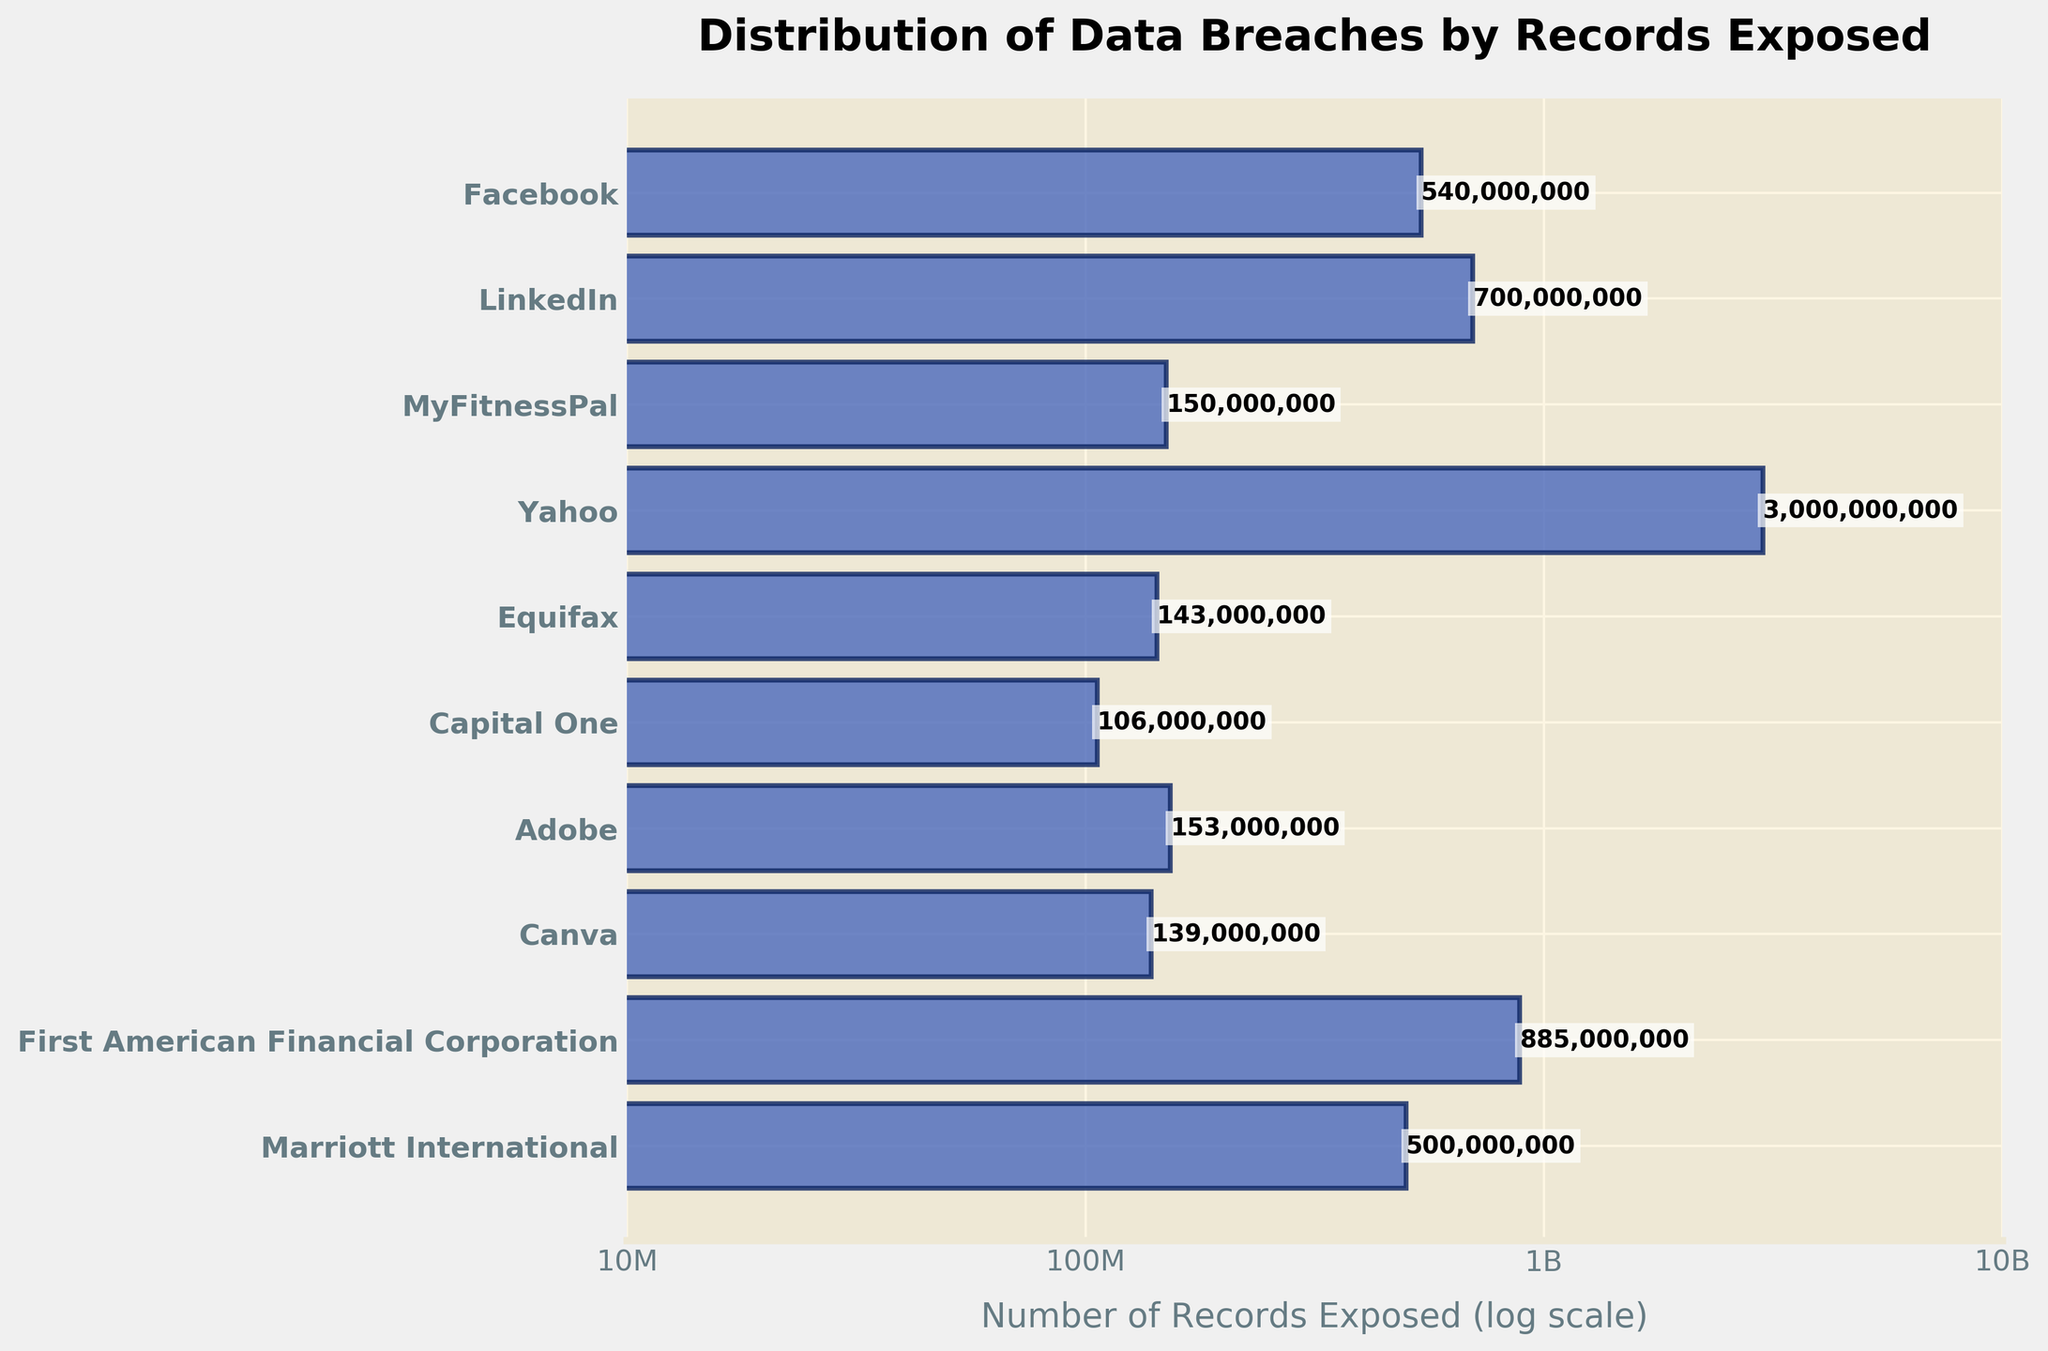what is the title of the plot? The title of the plot is located at the top of the figure. It should be read directly from there. The title provides context about what the figure represents.
Answer: Distribution of Data Breaches by Records Exposed which entity has the largest number of records exposed? Look for the bar that extends the farthest to the right on the horizontal axis. The label next to this bar represents the entity with the largest number of records exposed.
Answer: Yahoo how many records were exposed in the Yahoo data breach? Find the bar corresponding to Yahoo and look for the number displayed either next to the bar or consult the labels and their corresponding values on the x-axis.
Answer: 3,000,000,000 which two entities have the closest number of records exposed? Identify and compare bars that are closest in length on the horizontal axis to determine the entities with the closest number of exposed records.
Answer: Canva and Capital One what is the approximate difference in the number of records exposed between Facebook and LinkedIn? Approximate the length of the bars representing Facebook and LinkedIn, then calculate the difference between these values.
Answer: ~160,000,000 how many entities have breaches exposing more than 500 million records? Count the bars that extend past the "500M" mark on the x-axis. These are the entities with more than 500 million records exposed.
Answer: 4 are there more breaches exposing more than 100 million records or fewer than 100 million records? Count the number of bars on either side of the "100M" mark on the x-axis, and compare these counts to determine which group has more breaches.
Answer: More than 100 million which entity is listed first on the y-axis, and why is the order significant? Check the labels on the y-axis; the first entity listed at the top should be the one which had the least incidents based on the alignment of the bar. This order is significant because it is inverted, listing the entity with the smallest number of records exposed at the top and the largest at the bottom.
Answer: LinkedIn 